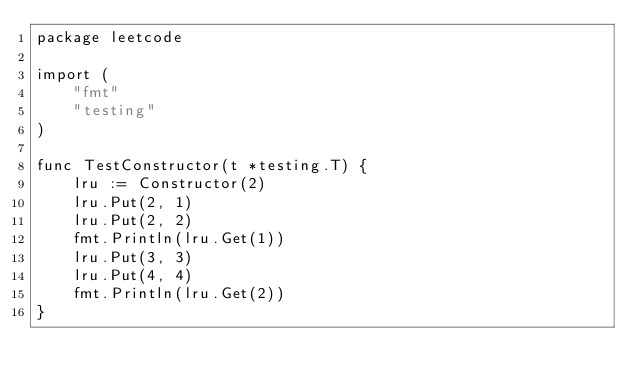<code> <loc_0><loc_0><loc_500><loc_500><_Go_>package leetcode

import (
	"fmt"
	"testing"
)

func TestConstructor(t *testing.T) {
	lru := Constructor(2)
	lru.Put(2, 1)
	lru.Put(2, 2)
	fmt.Println(lru.Get(1))
	lru.Put(3, 3)
	lru.Put(4, 4)
	fmt.Println(lru.Get(2))
}
</code> 